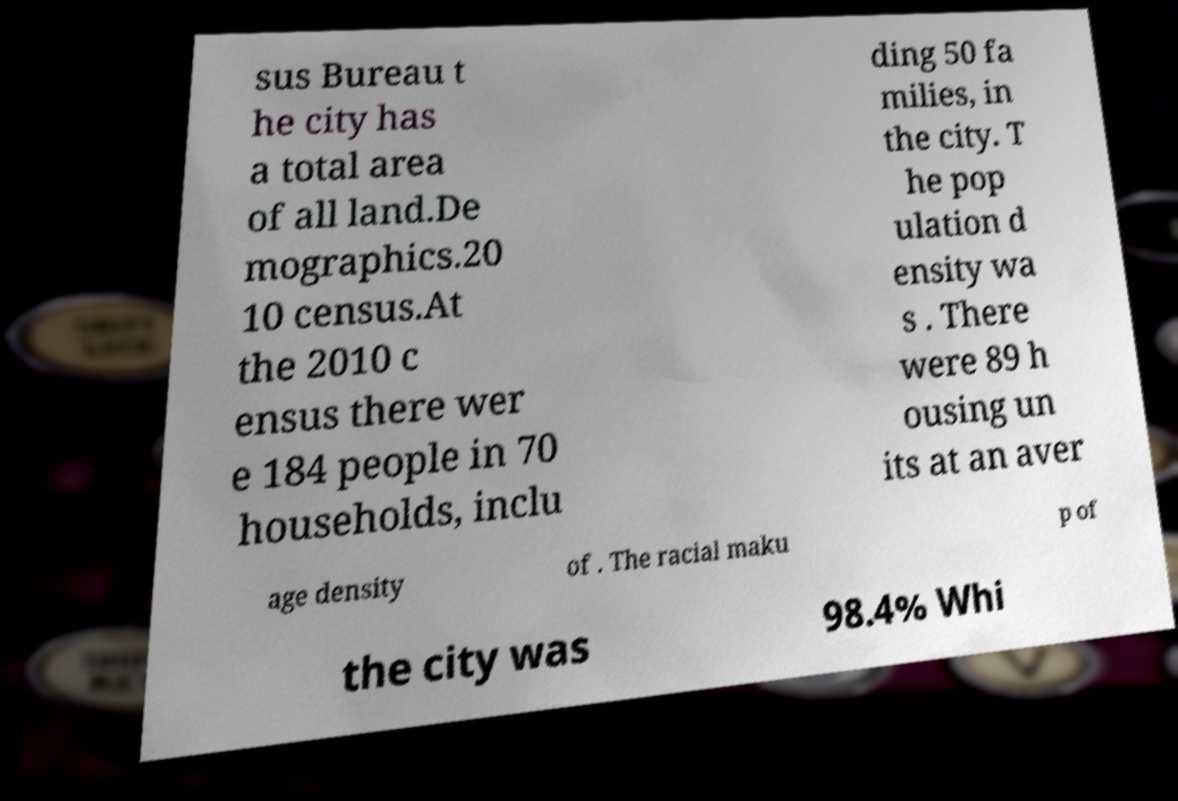Please identify and transcribe the text found in this image. sus Bureau t he city has a total area of all land.De mographics.20 10 census.At the 2010 c ensus there wer e 184 people in 70 households, inclu ding 50 fa milies, in the city. T he pop ulation d ensity wa s . There were 89 h ousing un its at an aver age density of . The racial maku p of the city was 98.4% Whi 